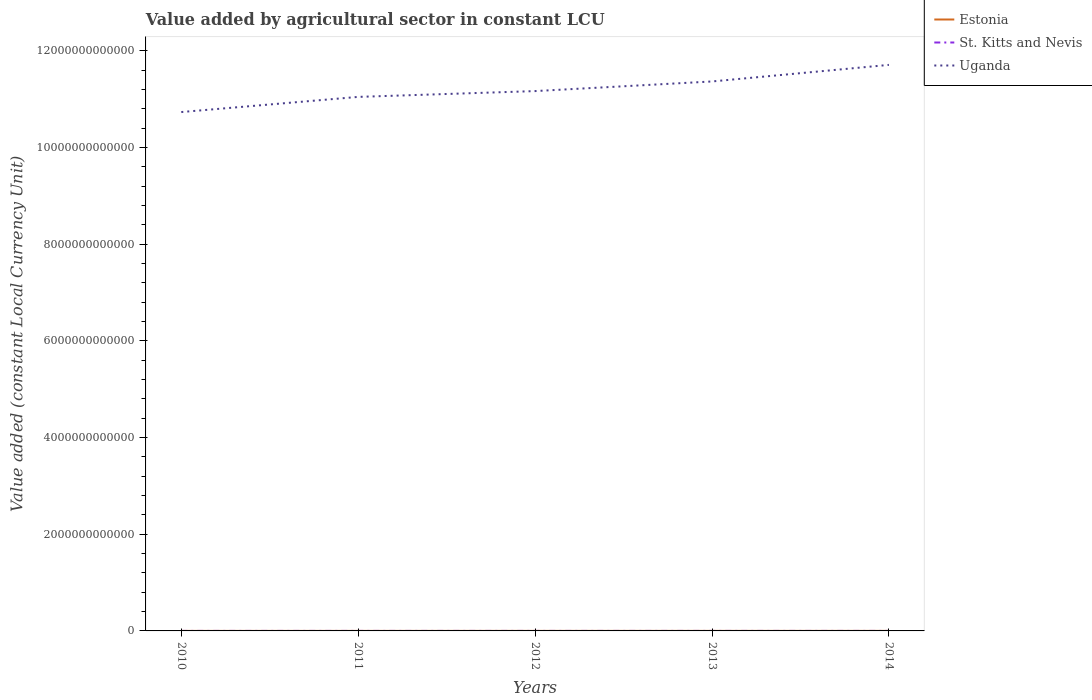How many different coloured lines are there?
Ensure brevity in your answer.  3. Across all years, what is the maximum value added by agricultural sector in St. Kitts and Nevis?
Offer a terse response. 2.07e+07. What is the total value added by agricultural sector in St. Kitts and Nevis in the graph?
Offer a very short reply. -1.33e+06. What is the difference between the highest and the second highest value added by agricultural sector in Estonia?
Your answer should be compact. 1.25e+08. What is the difference between the highest and the lowest value added by agricultural sector in Estonia?
Your response must be concise. 3. Is the value added by agricultural sector in Estonia strictly greater than the value added by agricultural sector in St. Kitts and Nevis over the years?
Keep it short and to the point. No. How many years are there in the graph?
Your response must be concise. 5. What is the difference between two consecutive major ticks on the Y-axis?
Your answer should be very brief. 2.00e+12. Does the graph contain grids?
Provide a succinct answer. No. How are the legend labels stacked?
Your answer should be compact. Vertical. What is the title of the graph?
Offer a very short reply. Value added by agricultural sector in constant LCU. Does "Caribbean small states" appear as one of the legend labels in the graph?
Offer a terse response. No. What is the label or title of the Y-axis?
Offer a very short reply. Value added (constant Local Currency Unit). What is the Value added (constant Local Currency Unit) in Estonia in 2010?
Make the answer very short. 4.11e+08. What is the Value added (constant Local Currency Unit) in St. Kitts and Nevis in 2010?
Offer a terse response. 2.07e+07. What is the Value added (constant Local Currency Unit) in Uganda in 2010?
Your answer should be compact. 1.07e+13. What is the Value added (constant Local Currency Unit) in Estonia in 2011?
Offer a terse response. 4.66e+08. What is the Value added (constant Local Currency Unit) in St. Kitts and Nevis in 2011?
Ensure brevity in your answer.  2.30e+07. What is the Value added (constant Local Currency Unit) in Uganda in 2011?
Make the answer very short. 1.10e+13. What is the Value added (constant Local Currency Unit) in Estonia in 2012?
Offer a terse response. 5.36e+08. What is the Value added (constant Local Currency Unit) in St. Kitts and Nevis in 2012?
Offer a terse response. 2.08e+07. What is the Value added (constant Local Currency Unit) in Uganda in 2012?
Your answer should be compact. 1.12e+13. What is the Value added (constant Local Currency Unit) of Estonia in 2013?
Make the answer very short. 5.01e+08. What is the Value added (constant Local Currency Unit) in St. Kitts and Nevis in 2013?
Offer a very short reply. 2.22e+07. What is the Value added (constant Local Currency Unit) in Uganda in 2013?
Give a very brief answer. 1.14e+13. What is the Value added (constant Local Currency Unit) in Estonia in 2014?
Offer a very short reply. 5.26e+08. What is the Value added (constant Local Currency Unit) of St. Kitts and Nevis in 2014?
Make the answer very short. 2.14e+07. What is the Value added (constant Local Currency Unit) in Uganda in 2014?
Your answer should be very brief. 1.17e+13. Across all years, what is the maximum Value added (constant Local Currency Unit) in Estonia?
Provide a short and direct response. 5.36e+08. Across all years, what is the maximum Value added (constant Local Currency Unit) of St. Kitts and Nevis?
Provide a succinct answer. 2.30e+07. Across all years, what is the maximum Value added (constant Local Currency Unit) in Uganda?
Your answer should be compact. 1.17e+13. Across all years, what is the minimum Value added (constant Local Currency Unit) in Estonia?
Make the answer very short. 4.11e+08. Across all years, what is the minimum Value added (constant Local Currency Unit) of St. Kitts and Nevis?
Offer a very short reply. 2.07e+07. Across all years, what is the minimum Value added (constant Local Currency Unit) of Uganda?
Offer a very short reply. 1.07e+13. What is the total Value added (constant Local Currency Unit) in Estonia in the graph?
Provide a succinct answer. 2.44e+09. What is the total Value added (constant Local Currency Unit) of St. Kitts and Nevis in the graph?
Ensure brevity in your answer.  1.08e+08. What is the total Value added (constant Local Currency Unit) in Uganda in the graph?
Offer a very short reply. 5.60e+13. What is the difference between the Value added (constant Local Currency Unit) in Estonia in 2010 and that in 2011?
Your answer should be compact. -5.49e+07. What is the difference between the Value added (constant Local Currency Unit) of St. Kitts and Nevis in 2010 and that in 2011?
Provide a succinct answer. -2.35e+06. What is the difference between the Value added (constant Local Currency Unit) of Uganda in 2010 and that in 2011?
Make the answer very short. -3.13e+11. What is the difference between the Value added (constant Local Currency Unit) in Estonia in 2010 and that in 2012?
Keep it short and to the point. -1.25e+08. What is the difference between the Value added (constant Local Currency Unit) in St. Kitts and Nevis in 2010 and that in 2012?
Your answer should be compact. -1.92e+05. What is the difference between the Value added (constant Local Currency Unit) in Uganda in 2010 and that in 2012?
Keep it short and to the point. -4.34e+11. What is the difference between the Value added (constant Local Currency Unit) of Estonia in 2010 and that in 2013?
Offer a very short reply. -8.96e+07. What is the difference between the Value added (constant Local Currency Unit) of St. Kitts and Nevis in 2010 and that in 2013?
Your answer should be compact. -1.53e+06. What is the difference between the Value added (constant Local Currency Unit) of Uganda in 2010 and that in 2013?
Ensure brevity in your answer.  -6.33e+11. What is the difference between the Value added (constant Local Currency Unit) in Estonia in 2010 and that in 2014?
Offer a very short reply. -1.15e+08. What is the difference between the Value added (constant Local Currency Unit) in St. Kitts and Nevis in 2010 and that in 2014?
Keep it short and to the point. -7.98e+05. What is the difference between the Value added (constant Local Currency Unit) in Uganda in 2010 and that in 2014?
Offer a terse response. -9.76e+11. What is the difference between the Value added (constant Local Currency Unit) of Estonia in 2011 and that in 2012?
Provide a succinct answer. -7.05e+07. What is the difference between the Value added (constant Local Currency Unit) of St. Kitts and Nevis in 2011 and that in 2012?
Your answer should be very brief. 2.16e+06. What is the difference between the Value added (constant Local Currency Unit) of Uganda in 2011 and that in 2012?
Keep it short and to the point. -1.20e+11. What is the difference between the Value added (constant Local Currency Unit) in Estonia in 2011 and that in 2013?
Your answer should be compact. -3.48e+07. What is the difference between the Value added (constant Local Currency Unit) of St. Kitts and Nevis in 2011 and that in 2013?
Ensure brevity in your answer.  8.26e+05. What is the difference between the Value added (constant Local Currency Unit) of Uganda in 2011 and that in 2013?
Give a very brief answer. -3.19e+11. What is the difference between the Value added (constant Local Currency Unit) of Estonia in 2011 and that in 2014?
Offer a very short reply. -6.05e+07. What is the difference between the Value added (constant Local Currency Unit) in St. Kitts and Nevis in 2011 and that in 2014?
Provide a succinct answer. 1.56e+06. What is the difference between the Value added (constant Local Currency Unit) in Uganda in 2011 and that in 2014?
Give a very brief answer. -6.62e+11. What is the difference between the Value added (constant Local Currency Unit) of Estonia in 2012 and that in 2013?
Ensure brevity in your answer.  3.58e+07. What is the difference between the Value added (constant Local Currency Unit) in St. Kitts and Nevis in 2012 and that in 2013?
Provide a short and direct response. -1.33e+06. What is the difference between the Value added (constant Local Currency Unit) in Uganda in 2012 and that in 2013?
Offer a very short reply. -1.99e+11. What is the difference between the Value added (constant Local Currency Unit) in Estonia in 2012 and that in 2014?
Your answer should be very brief. 1.01e+07. What is the difference between the Value added (constant Local Currency Unit) of St. Kitts and Nevis in 2012 and that in 2014?
Provide a short and direct response. -6.05e+05. What is the difference between the Value added (constant Local Currency Unit) in Uganda in 2012 and that in 2014?
Give a very brief answer. -5.42e+11. What is the difference between the Value added (constant Local Currency Unit) of Estonia in 2013 and that in 2014?
Your response must be concise. -2.57e+07. What is the difference between the Value added (constant Local Currency Unit) of St. Kitts and Nevis in 2013 and that in 2014?
Offer a very short reply. 7.30e+05. What is the difference between the Value added (constant Local Currency Unit) of Uganda in 2013 and that in 2014?
Make the answer very short. -3.43e+11. What is the difference between the Value added (constant Local Currency Unit) in Estonia in 2010 and the Value added (constant Local Currency Unit) in St. Kitts and Nevis in 2011?
Provide a succinct answer. 3.88e+08. What is the difference between the Value added (constant Local Currency Unit) of Estonia in 2010 and the Value added (constant Local Currency Unit) of Uganda in 2011?
Your answer should be compact. -1.10e+13. What is the difference between the Value added (constant Local Currency Unit) in St. Kitts and Nevis in 2010 and the Value added (constant Local Currency Unit) in Uganda in 2011?
Make the answer very short. -1.10e+13. What is the difference between the Value added (constant Local Currency Unit) of Estonia in 2010 and the Value added (constant Local Currency Unit) of St. Kitts and Nevis in 2012?
Give a very brief answer. 3.90e+08. What is the difference between the Value added (constant Local Currency Unit) of Estonia in 2010 and the Value added (constant Local Currency Unit) of Uganda in 2012?
Your answer should be very brief. -1.12e+13. What is the difference between the Value added (constant Local Currency Unit) of St. Kitts and Nevis in 2010 and the Value added (constant Local Currency Unit) of Uganda in 2012?
Your answer should be very brief. -1.12e+13. What is the difference between the Value added (constant Local Currency Unit) in Estonia in 2010 and the Value added (constant Local Currency Unit) in St. Kitts and Nevis in 2013?
Your answer should be very brief. 3.89e+08. What is the difference between the Value added (constant Local Currency Unit) of Estonia in 2010 and the Value added (constant Local Currency Unit) of Uganda in 2013?
Make the answer very short. -1.14e+13. What is the difference between the Value added (constant Local Currency Unit) in St. Kitts and Nevis in 2010 and the Value added (constant Local Currency Unit) in Uganda in 2013?
Keep it short and to the point. -1.14e+13. What is the difference between the Value added (constant Local Currency Unit) of Estonia in 2010 and the Value added (constant Local Currency Unit) of St. Kitts and Nevis in 2014?
Provide a succinct answer. 3.90e+08. What is the difference between the Value added (constant Local Currency Unit) of Estonia in 2010 and the Value added (constant Local Currency Unit) of Uganda in 2014?
Your response must be concise. -1.17e+13. What is the difference between the Value added (constant Local Currency Unit) in St. Kitts and Nevis in 2010 and the Value added (constant Local Currency Unit) in Uganda in 2014?
Your response must be concise. -1.17e+13. What is the difference between the Value added (constant Local Currency Unit) in Estonia in 2011 and the Value added (constant Local Currency Unit) in St. Kitts and Nevis in 2012?
Your answer should be very brief. 4.45e+08. What is the difference between the Value added (constant Local Currency Unit) in Estonia in 2011 and the Value added (constant Local Currency Unit) in Uganda in 2012?
Keep it short and to the point. -1.12e+13. What is the difference between the Value added (constant Local Currency Unit) in St. Kitts and Nevis in 2011 and the Value added (constant Local Currency Unit) in Uganda in 2012?
Provide a succinct answer. -1.12e+13. What is the difference between the Value added (constant Local Currency Unit) of Estonia in 2011 and the Value added (constant Local Currency Unit) of St. Kitts and Nevis in 2013?
Offer a terse response. 4.44e+08. What is the difference between the Value added (constant Local Currency Unit) in Estonia in 2011 and the Value added (constant Local Currency Unit) in Uganda in 2013?
Provide a short and direct response. -1.14e+13. What is the difference between the Value added (constant Local Currency Unit) in St. Kitts and Nevis in 2011 and the Value added (constant Local Currency Unit) in Uganda in 2013?
Provide a short and direct response. -1.14e+13. What is the difference between the Value added (constant Local Currency Unit) of Estonia in 2011 and the Value added (constant Local Currency Unit) of St. Kitts and Nevis in 2014?
Provide a succinct answer. 4.44e+08. What is the difference between the Value added (constant Local Currency Unit) of Estonia in 2011 and the Value added (constant Local Currency Unit) of Uganda in 2014?
Your answer should be compact. -1.17e+13. What is the difference between the Value added (constant Local Currency Unit) of St. Kitts and Nevis in 2011 and the Value added (constant Local Currency Unit) of Uganda in 2014?
Offer a terse response. -1.17e+13. What is the difference between the Value added (constant Local Currency Unit) in Estonia in 2012 and the Value added (constant Local Currency Unit) in St. Kitts and Nevis in 2013?
Your answer should be very brief. 5.14e+08. What is the difference between the Value added (constant Local Currency Unit) in Estonia in 2012 and the Value added (constant Local Currency Unit) in Uganda in 2013?
Offer a very short reply. -1.14e+13. What is the difference between the Value added (constant Local Currency Unit) in St. Kitts and Nevis in 2012 and the Value added (constant Local Currency Unit) in Uganda in 2013?
Your response must be concise. -1.14e+13. What is the difference between the Value added (constant Local Currency Unit) of Estonia in 2012 and the Value added (constant Local Currency Unit) of St. Kitts and Nevis in 2014?
Your answer should be very brief. 5.15e+08. What is the difference between the Value added (constant Local Currency Unit) of Estonia in 2012 and the Value added (constant Local Currency Unit) of Uganda in 2014?
Provide a succinct answer. -1.17e+13. What is the difference between the Value added (constant Local Currency Unit) in St. Kitts and Nevis in 2012 and the Value added (constant Local Currency Unit) in Uganda in 2014?
Your answer should be compact. -1.17e+13. What is the difference between the Value added (constant Local Currency Unit) in Estonia in 2013 and the Value added (constant Local Currency Unit) in St. Kitts and Nevis in 2014?
Offer a terse response. 4.79e+08. What is the difference between the Value added (constant Local Currency Unit) in Estonia in 2013 and the Value added (constant Local Currency Unit) in Uganda in 2014?
Provide a succinct answer. -1.17e+13. What is the difference between the Value added (constant Local Currency Unit) in St. Kitts and Nevis in 2013 and the Value added (constant Local Currency Unit) in Uganda in 2014?
Your response must be concise. -1.17e+13. What is the average Value added (constant Local Currency Unit) of Estonia per year?
Your response must be concise. 4.88e+08. What is the average Value added (constant Local Currency Unit) in St. Kitts and Nevis per year?
Offer a very short reply. 2.16e+07. What is the average Value added (constant Local Currency Unit) in Uganda per year?
Give a very brief answer. 1.12e+13. In the year 2010, what is the difference between the Value added (constant Local Currency Unit) in Estonia and Value added (constant Local Currency Unit) in St. Kitts and Nevis?
Your response must be concise. 3.90e+08. In the year 2010, what is the difference between the Value added (constant Local Currency Unit) of Estonia and Value added (constant Local Currency Unit) of Uganda?
Offer a very short reply. -1.07e+13. In the year 2010, what is the difference between the Value added (constant Local Currency Unit) of St. Kitts and Nevis and Value added (constant Local Currency Unit) of Uganda?
Keep it short and to the point. -1.07e+13. In the year 2011, what is the difference between the Value added (constant Local Currency Unit) in Estonia and Value added (constant Local Currency Unit) in St. Kitts and Nevis?
Offer a very short reply. 4.43e+08. In the year 2011, what is the difference between the Value added (constant Local Currency Unit) of Estonia and Value added (constant Local Currency Unit) of Uganda?
Ensure brevity in your answer.  -1.10e+13. In the year 2011, what is the difference between the Value added (constant Local Currency Unit) in St. Kitts and Nevis and Value added (constant Local Currency Unit) in Uganda?
Offer a very short reply. -1.10e+13. In the year 2012, what is the difference between the Value added (constant Local Currency Unit) of Estonia and Value added (constant Local Currency Unit) of St. Kitts and Nevis?
Give a very brief answer. 5.16e+08. In the year 2012, what is the difference between the Value added (constant Local Currency Unit) of Estonia and Value added (constant Local Currency Unit) of Uganda?
Give a very brief answer. -1.12e+13. In the year 2012, what is the difference between the Value added (constant Local Currency Unit) in St. Kitts and Nevis and Value added (constant Local Currency Unit) in Uganda?
Make the answer very short. -1.12e+13. In the year 2013, what is the difference between the Value added (constant Local Currency Unit) in Estonia and Value added (constant Local Currency Unit) in St. Kitts and Nevis?
Offer a very short reply. 4.79e+08. In the year 2013, what is the difference between the Value added (constant Local Currency Unit) of Estonia and Value added (constant Local Currency Unit) of Uganda?
Keep it short and to the point. -1.14e+13. In the year 2013, what is the difference between the Value added (constant Local Currency Unit) of St. Kitts and Nevis and Value added (constant Local Currency Unit) of Uganda?
Keep it short and to the point. -1.14e+13. In the year 2014, what is the difference between the Value added (constant Local Currency Unit) of Estonia and Value added (constant Local Currency Unit) of St. Kitts and Nevis?
Your answer should be compact. 5.05e+08. In the year 2014, what is the difference between the Value added (constant Local Currency Unit) in Estonia and Value added (constant Local Currency Unit) in Uganda?
Give a very brief answer. -1.17e+13. In the year 2014, what is the difference between the Value added (constant Local Currency Unit) in St. Kitts and Nevis and Value added (constant Local Currency Unit) in Uganda?
Give a very brief answer. -1.17e+13. What is the ratio of the Value added (constant Local Currency Unit) in Estonia in 2010 to that in 2011?
Your response must be concise. 0.88. What is the ratio of the Value added (constant Local Currency Unit) in St. Kitts and Nevis in 2010 to that in 2011?
Offer a terse response. 0.9. What is the ratio of the Value added (constant Local Currency Unit) of Uganda in 2010 to that in 2011?
Provide a short and direct response. 0.97. What is the ratio of the Value added (constant Local Currency Unit) of Estonia in 2010 to that in 2012?
Offer a terse response. 0.77. What is the ratio of the Value added (constant Local Currency Unit) of Uganda in 2010 to that in 2012?
Offer a terse response. 0.96. What is the ratio of the Value added (constant Local Currency Unit) in Estonia in 2010 to that in 2013?
Ensure brevity in your answer.  0.82. What is the ratio of the Value added (constant Local Currency Unit) of St. Kitts and Nevis in 2010 to that in 2013?
Offer a very short reply. 0.93. What is the ratio of the Value added (constant Local Currency Unit) of Uganda in 2010 to that in 2013?
Provide a succinct answer. 0.94. What is the ratio of the Value added (constant Local Currency Unit) of Estonia in 2010 to that in 2014?
Your answer should be very brief. 0.78. What is the ratio of the Value added (constant Local Currency Unit) in St. Kitts and Nevis in 2010 to that in 2014?
Ensure brevity in your answer.  0.96. What is the ratio of the Value added (constant Local Currency Unit) in Estonia in 2011 to that in 2012?
Offer a very short reply. 0.87. What is the ratio of the Value added (constant Local Currency Unit) in St. Kitts and Nevis in 2011 to that in 2012?
Your response must be concise. 1.1. What is the ratio of the Value added (constant Local Currency Unit) in Uganda in 2011 to that in 2012?
Provide a short and direct response. 0.99. What is the ratio of the Value added (constant Local Currency Unit) of Estonia in 2011 to that in 2013?
Provide a short and direct response. 0.93. What is the ratio of the Value added (constant Local Currency Unit) of St. Kitts and Nevis in 2011 to that in 2013?
Keep it short and to the point. 1.04. What is the ratio of the Value added (constant Local Currency Unit) in Uganda in 2011 to that in 2013?
Your answer should be compact. 0.97. What is the ratio of the Value added (constant Local Currency Unit) in Estonia in 2011 to that in 2014?
Keep it short and to the point. 0.89. What is the ratio of the Value added (constant Local Currency Unit) in St. Kitts and Nevis in 2011 to that in 2014?
Make the answer very short. 1.07. What is the ratio of the Value added (constant Local Currency Unit) in Uganda in 2011 to that in 2014?
Ensure brevity in your answer.  0.94. What is the ratio of the Value added (constant Local Currency Unit) in Estonia in 2012 to that in 2013?
Your answer should be very brief. 1.07. What is the ratio of the Value added (constant Local Currency Unit) of St. Kitts and Nevis in 2012 to that in 2013?
Offer a terse response. 0.94. What is the ratio of the Value added (constant Local Currency Unit) in Uganda in 2012 to that in 2013?
Ensure brevity in your answer.  0.98. What is the ratio of the Value added (constant Local Currency Unit) in Estonia in 2012 to that in 2014?
Your answer should be very brief. 1.02. What is the ratio of the Value added (constant Local Currency Unit) of St. Kitts and Nevis in 2012 to that in 2014?
Offer a terse response. 0.97. What is the ratio of the Value added (constant Local Currency Unit) in Uganda in 2012 to that in 2014?
Give a very brief answer. 0.95. What is the ratio of the Value added (constant Local Currency Unit) in Estonia in 2013 to that in 2014?
Your answer should be very brief. 0.95. What is the ratio of the Value added (constant Local Currency Unit) in St. Kitts and Nevis in 2013 to that in 2014?
Ensure brevity in your answer.  1.03. What is the ratio of the Value added (constant Local Currency Unit) of Uganda in 2013 to that in 2014?
Provide a succinct answer. 0.97. What is the difference between the highest and the second highest Value added (constant Local Currency Unit) of Estonia?
Offer a terse response. 1.01e+07. What is the difference between the highest and the second highest Value added (constant Local Currency Unit) in St. Kitts and Nevis?
Your response must be concise. 8.26e+05. What is the difference between the highest and the second highest Value added (constant Local Currency Unit) in Uganda?
Make the answer very short. 3.43e+11. What is the difference between the highest and the lowest Value added (constant Local Currency Unit) of Estonia?
Ensure brevity in your answer.  1.25e+08. What is the difference between the highest and the lowest Value added (constant Local Currency Unit) in St. Kitts and Nevis?
Your response must be concise. 2.35e+06. What is the difference between the highest and the lowest Value added (constant Local Currency Unit) of Uganda?
Give a very brief answer. 9.76e+11. 